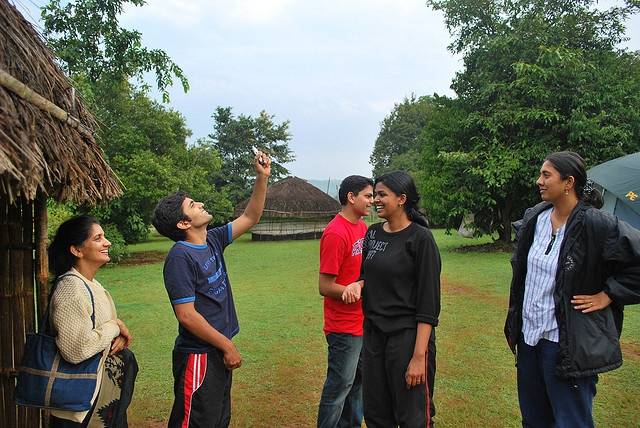Describe the objects in this image and their specific colors. I can see people in gray, black, and darkgray tones, people in gray, black, and brown tones, people in gray, black, and brown tones, people in gray, black, and tan tones, and people in gray, black, red, and brown tones in this image. 